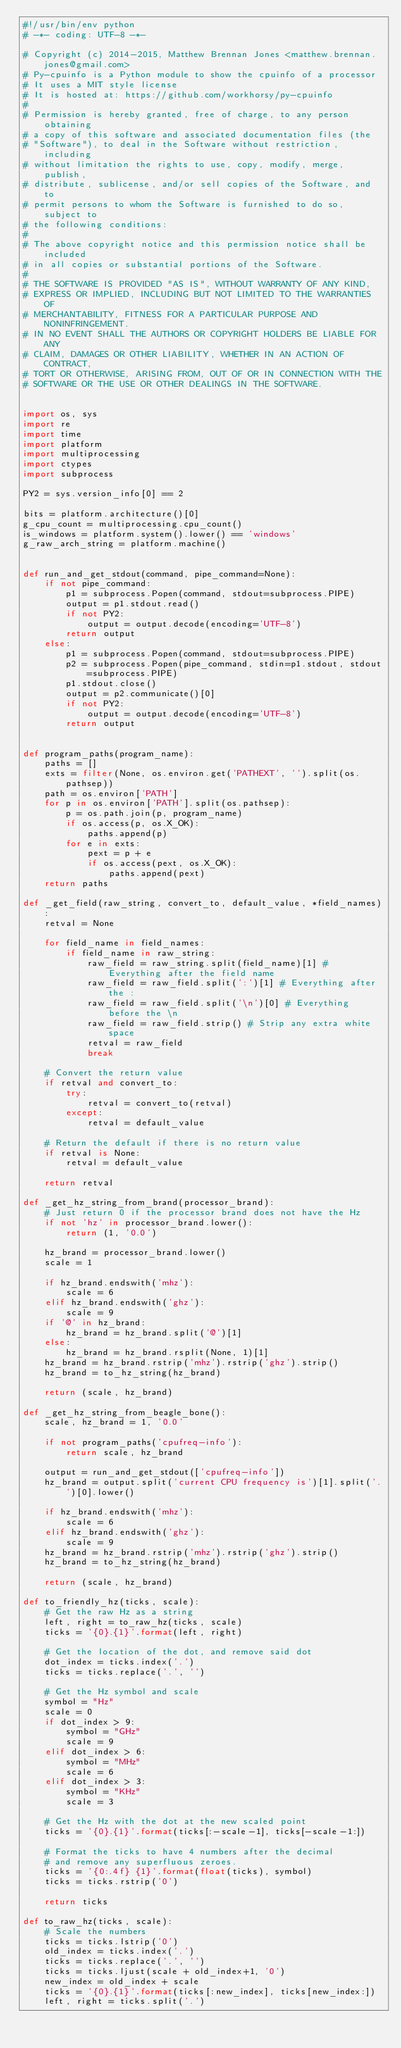Convert code to text. <code><loc_0><loc_0><loc_500><loc_500><_Python_>#!/usr/bin/env python
# -*- coding: UTF-8 -*-

# Copyright (c) 2014-2015, Matthew Brennan Jones <matthew.brennan.jones@gmail.com>
# Py-cpuinfo is a Python module to show the cpuinfo of a processor
# It uses a MIT style license
# It is hosted at: https://github.com/workhorsy/py-cpuinfo
#
# Permission is hereby granted, free of charge, to any person obtaining
# a copy of this software and associated documentation files (the
# "Software"), to deal in the Software without restriction, including
# without limitation the rights to use, copy, modify, merge, publish,
# distribute, sublicense, and/or sell copies of the Software, and to
# permit persons to whom the Software is furnished to do so, subject to
# the following conditions:
#
# The above copyright notice and this permission notice shall be included
# in all copies or substantial portions of the Software.
#
# THE SOFTWARE IS PROVIDED "AS IS", WITHOUT WARRANTY OF ANY KIND,
# EXPRESS OR IMPLIED, INCLUDING BUT NOT LIMITED TO THE WARRANTIES OF
# MERCHANTABILITY, FITNESS FOR A PARTICULAR PURPOSE AND NONINFRINGEMENT.
# IN NO EVENT SHALL THE AUTHORS OR COPYRIGHT HOLDERS BE LIABLE FOR ANY
# CLAIM, DAMAGES OR OTHER LIABILITY, WHETHER IN AN ACTION OF CONTRACT,
# TORT OR OTHERWISE, ARISING FROM, OUT OF OR IN CONNECTION WITH THE
# SOFTWARE OR THE USE OR OTHER DEALINGS IN THE SOFTWARE.


import os, sys
import re
import time
import platform
import multiprocessing
import ctypes
import subprocess

PY2 = sys.version_info[0] == 2

bits = platform.architecture()[0]
g_cpu_count = multiprocessing.cpu_count()
is_windows = platform.system().lower() == 'windows'
g_raw_arch_string = platform.machine()


def run_and_get_stdout(command, pipe_command=None):
	if not pipe_command:
		p1 = subprocess.Popen(command, stdout=subprocess.PIPE)
		output = p1.stdout.read()
		if not PY2:
			output = output.decode(encoding='UTF-8')
		return output
	else:
		p1 = subprocess.Popen(command, stdout=subprocess.PIPE)
		p2 = subprocess.Popen(pipe_command, stdin=p1.stdout, stdout=subprocess.PIPE)
		p1.stdout.close()
		output = p2.communicate()[0]
		if not PY2:
			output = output.decode(encoding='UTF-8')
		return output


def program_paths(program_name):
	paths = []
	exts = filter(None, os.environ.get('PATHEXT', '').split(os.pathsep))
	path = os.environ['PATH']
	for p in os.environ['PATH'].split(os.pathsep):
		p = os.path.join(p, program_name)
		if os.access(p, os.X_OK):
			paths.append(p)
		for e in exts:
			pext = p + e
			if os.access(pext, os.X_OK):
				paths.append(pext)
	return paths

def _get_field(raw_string, convert_to, default_value, *field_names):
	retval = None

	for field_name in field_names:
		if field_name in raw_string:
			raw_field = raw_string.split(field_name)[1] # Everything after the field name
			raw_field = raw_field.split(':')[1] # Everything after the :
			raw_field = raw_field.split('\n')[0] # Everything before the \n
			raw_field = raw_field.strip() # Strip any extra white space
			retval = raw_field
			break

	# Convert the return value
	if retval and convert_to:
		try:
			retval = convert_to(retval)
		except:
			retval = default_value

	# Return the default if there is no return value
	if retval is None:
		retval = default_value

	return retval

def _get_hz_string_from_brand(processor_brand):
	# Just return 0 if the processor brand does not have the Hz
	if not 'hz' in processor_brand.lower():
		return (1, '0.0')

	hz_brand = processor_brand.lower()
	scale = 1

	if hz_brand.endswith('mhz'):
		scale = 6
	elif hz_brand.endswith('ghz'):
		scale = 9
	if '@' in hz_brand:
		hz_brand = hz_brand.split('@')[1]
	else:
		hz_brand = hz_brand.rsplit(None, 1)[1]
	hz_brand = hz_brand.rstrip('mhz').rstrip('ghz').strip()
	hz_brand = to_hz_string(hz_brand)

	return (scale, hz_brand)

def _get_hz_string_from_beagle_bone():
	scale, hz_brand = 1, '0.0'

	if not program_paths('cpufreq-info'):
		return scale, hz_brand

	output = run_and_get_stdout(['cpufreq-info'])
	hz_brand = output.split('current CPU frequency is')[1].split('.')[0].lower()

	if hz_brand.endswith('mhz'):
		scale = 6
	elif hz_brand.endswith('ghz'):
		scale = 9
	hz_brand = hz_brand.rstrip('mhz').rstrip('ghz').strip()
	hz_brand = to_hz_string(hz_brand)

	return (scale, hz_brand)

def to_friendly_hz(ticks, scale):
	# Get the raw Hz as a string
	left, right = to_raw_hz(ticks, scale)
	ticks = '{0}.{1}'.format(left, right)

	# Get the location of the dot, and remove said dot
	dot_index = ticks.index('.')
	ticks = ticks.replace('.', '')

	# Get the Hz symbol and scale
	symbol = "Hz"
	scale = 0
	if dot_index > 9:
		symbol = "GHz"
		scale = 9
	elif dot_index > 6:
		symbol = "MHz"
		scale = 6
	elif dot_index > 3:
		symbol = "KHz"
		scale = 3

	# Get the Hz with the dot at the new scaled point
	ticks = '{0}.{1}'.format(ticks[:-scale-1], ticks[-scale-1:])

	# Format the ticks to have 4 numbers after the decimal
	# and remove any superfluous zeroes.
	ticks = '{0:.4f} {1}'.format(float(ticks), symbol)
	ticks = ticks.rstrip('0')

	return ticks

def to_raw_hz(ticks, scale):
	# Scale the numbers
	ticks = ticks.lstrip('0')
	old_index = ticks.index('.')
	ticks = ticks.replace('.', '')
	ticks = ticks.ljust(scale + old_index+1, '0')
	new_index = old_index + scale
	ticks = '{0}.{1}'.format(ticks[:new_index], ticks[new_index:])
	left, right = ticks.split('.')</code> 